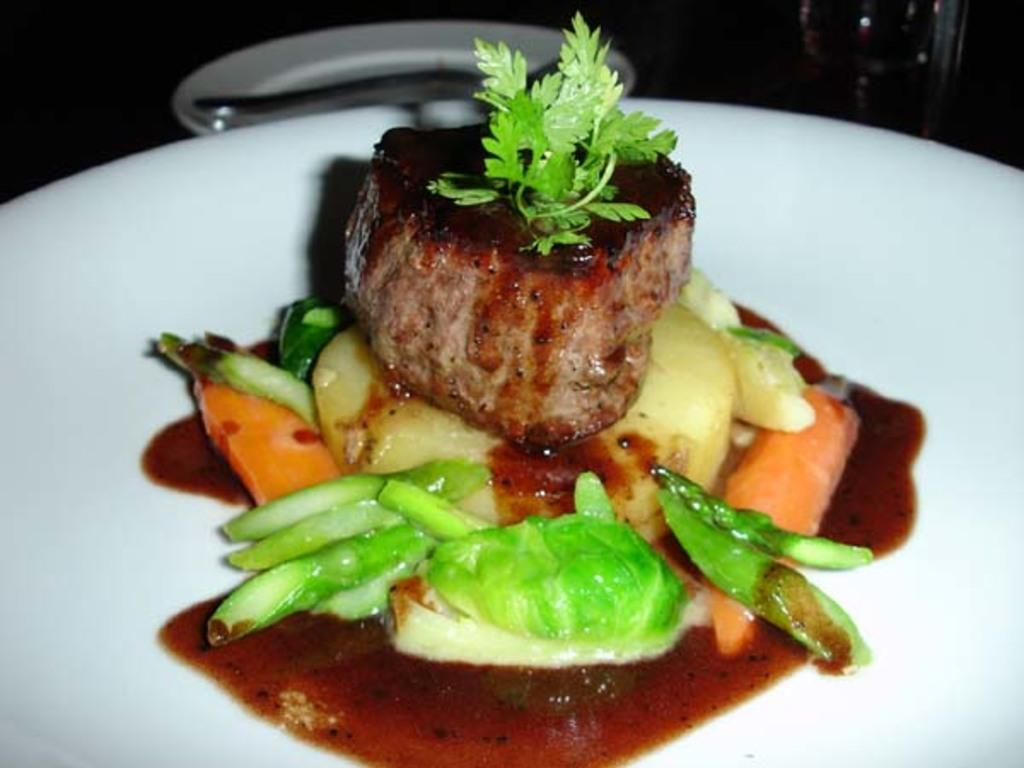What can be seen on the plate in the image? There is a food item on the plate in the image. Can you describe the food item on the plate? Unfortunately, the specific food item cannot be determined from the provided facts. How does the wilderness affect the plate in the image? There is no wilderness present in the image, so it cannot affect the plate. 